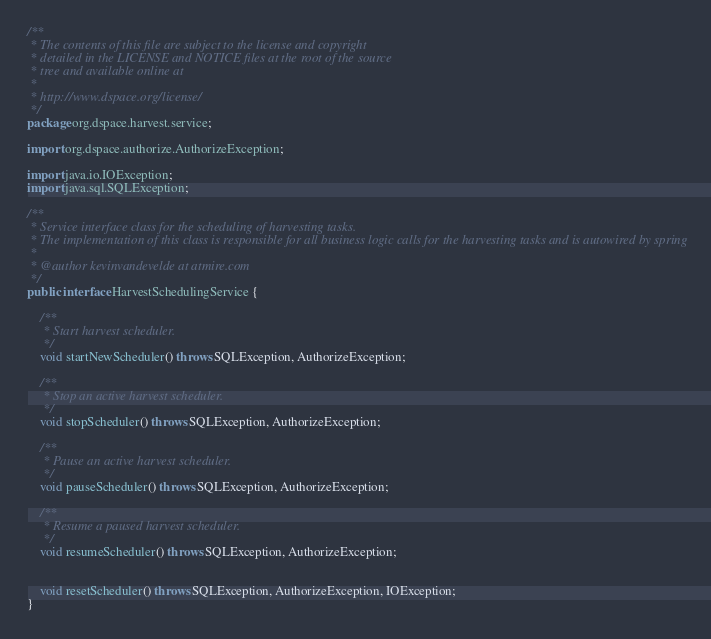Convert code to text. <code><loc_0><loc_0><loc_500><loc_500><_Java_>/**
 * The contents of this file are subject to the license and copyright
 * detailed in the LICENSE and NOTICE files at the root of the source
 * tree and available online at
 *
 * http://www.dspace.org/license/
 */
package org.dspace.harvest.service;

import org.dspace.authorize.AuthorizeException;

import java.io.IOException;
import java.sql.SQLException;

/**
 * Service interface class for the scheduling of harvesting tasks.
 * The implementation of this class is responsible for all business logic calls for the harvesting tasks and is autowired by spring
 *
 * @author kevinvandevelde at atmire.com
 */
public interface HarvestSchedulingService {

    /**
     * Start harvest scheduler.
     */
    void startNewScheduler() throws SQLException, AuthorizeException;

    /**
     * Stop an active harvest scheduler.
     */
    void stopScheduler() throws SQLException, AuthorizeException;

    /**
   	 * Pause an active harvest scheduler.
   	 */
    void pauseScheduler() throws SQLException, AuthorizeException;

    /**
   	 * Resume a paused harvest scheduler.
   	 */
    void resumeScheduler() throws SQLException, AuthorizeException;


    void resetScheduler() throws SQLException, AuthorizeException, IOException;
}
</code> 